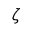Convert formula to latex. <formula><loc_0><loc_0><loc_500><loc_500>\zeta</formula> 